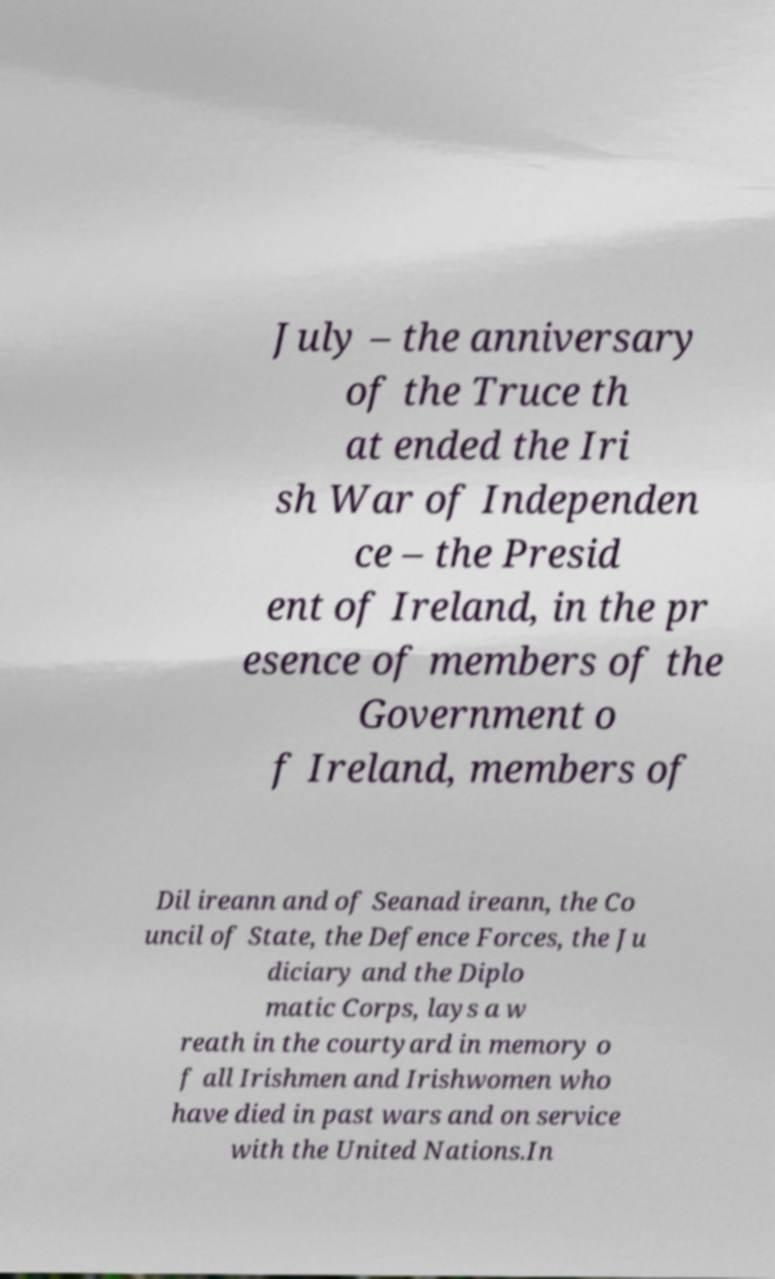Could you extract and type out the text from this image? July – the anniversary of the Truce th at ended the Iri sh War of Independen ce – the Presid ent of Ireland, in the pr esence of members of the Government o f Ireland, members of Dil ireann and of Seanad ireann, the Co uncil of State, the Defence Forces, the Ju diciary and the Diplo matic Corps, lays a w reath in the courtyard in memory o f all Irishmen and Irishwomen who have died in past wars and on service with the United Nations.In 